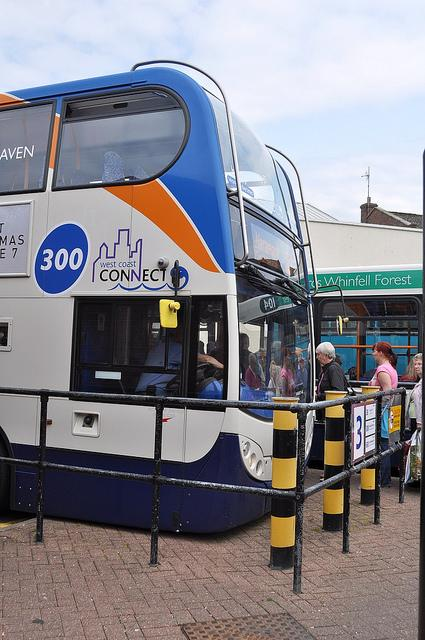The bus in the background is going to the home of which endangered animal? Please explain your reasoning. red squirrel. The bus is home to the red squirrel. 